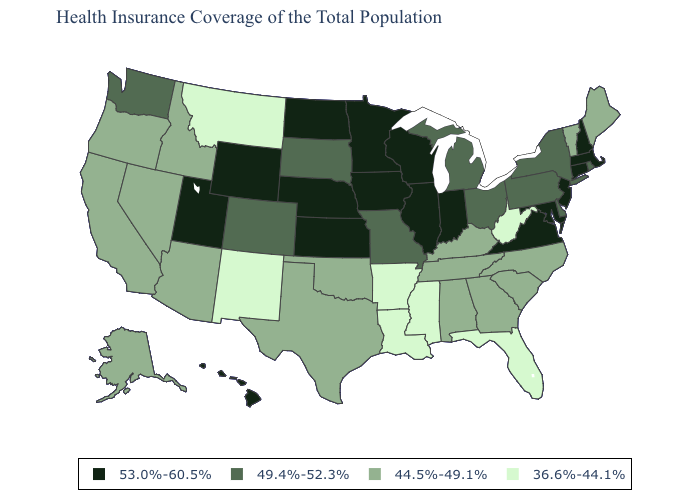Name the states that have a value in the range 53.0%-60.5%?
Quick response, please. Connecticut, Hawaii, Illinois, Indiana, Iowa, Kansas, Maryland, Massachusetts, Minnesota, Nebraska, New Hampshire, New Jersey, North Dakota, Utah, Virginia, Wisconsin, Wyoming. Name the states that have a value in the range 44.5%-49.1%?
Short answer required. Alabama, Alaska, Arizona, California, Georgia, Idaho, Kentucky, Maine, Nevada, North Carolina, Oklahoma, Oregon, South Carolina, Tennessee, Texas, Vermont. Name the states that have a value in the range 53.0%-60.5%?
Short answer required. Connecticut, Hawaii, Illinois, Indiana, Iowa, Kansas, Maryland, Massachusetts, Minnesota, Nebraska, New Hampshire, New Jersey, North Dakota, Utah, Virginia, Wisconsin, Wyoming. Does Mississippi have the lowest value in the USA?
Write a very short answer. Yes. Name the states that have a value in the range 53.0%-60.5%?
Write a very short answer. Connecticut, Hawaii, Illinois, Indiana, Iowa, Kansas, Maryland, Massachusetts, Minnesota, Nebraska, New Hampshire, New Jersey, North Dakota, Utah, Virginia, Wisconsin, Wyoming. Does Utah have the highest value in the West?
Answer briefly. Yes. What is the value of Connecticut?
Quick response, please. 53.0%-60.5%. Does North Dakota have the lowest value in the MidWest?
Short answer required. No. What is the value of Arkansas?
Give a very brief answer. 36.6%-44.1%. Which states hav the highest value in the West?
Keep it brief. Hawaii, Utah, Wyoming. Which states have the highest value in the USA?
Keep it brief. Connecticut, Hawaii, Illinois, Indiana, Iowa, Kansas, Maryland, Massachusetts, Minnesota, Nebraska, New Hampshire, New Jersey, North Dakota, Utah, Virginia, Wisconsin, Wyoming. What is the lowest value in the South?
Concise answer only. 36.6%-44.1%. Name the states that have a value in the range 36.6%-44.1%?
Keep it brief. Arkansas, Florida, Louisiana, Mississippi, Montana, New Mexico, West Virginia. Which states have the lowest value in the Northeast?
Concise answer only. Maine, Vermont. Does Missouri have a lower value than Massachusetts?
Quick response, please. Yes. 